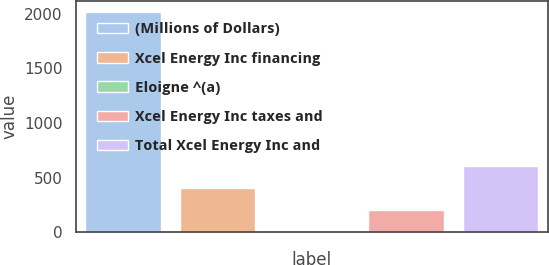<chart> <loc_0><loc_0><loc_500><loc_500><bar_chart><fcel>(Millions of Dollars)<fcel>Xcel Energy Inc financing<fcel>Eloigne ^(a)<fcel>Xcel Energy Inc taxes and<fcel>Total Xcel Energy Inc and<nl><fcel>2015<fcel>403.08<fcel>0.1<fcel>201.59<fcel>604.57<nl></chart> 